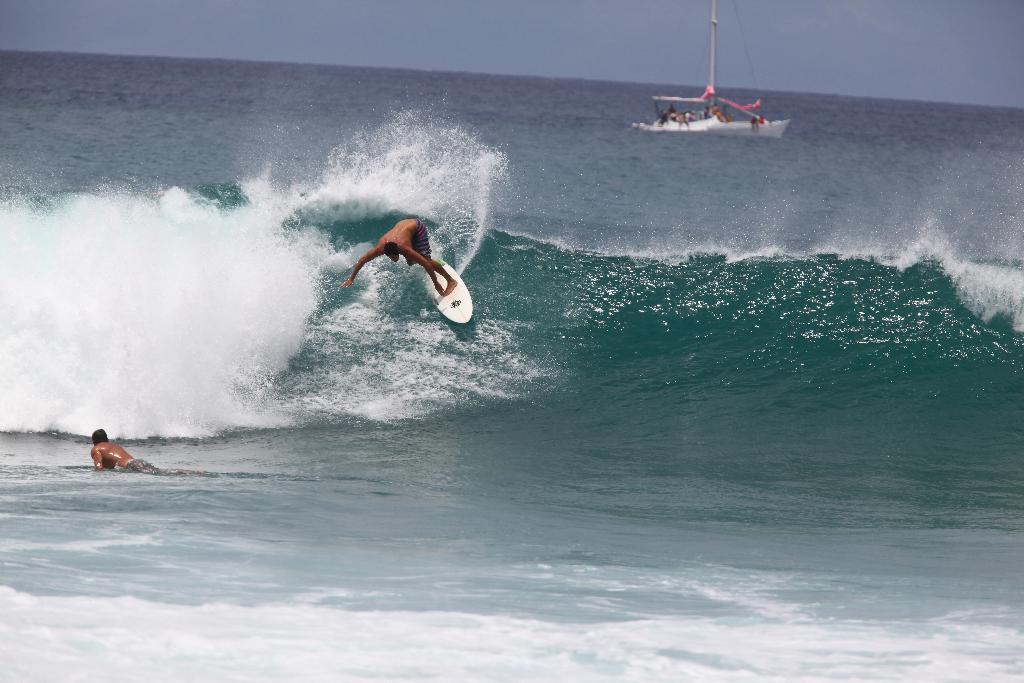How would you summarize this image in a sentence or two? This image consists of an ocean. In the front, we can see two persons surfing. In the background, there is a boat. At the top, there is sky. The surfboard is in white color. 